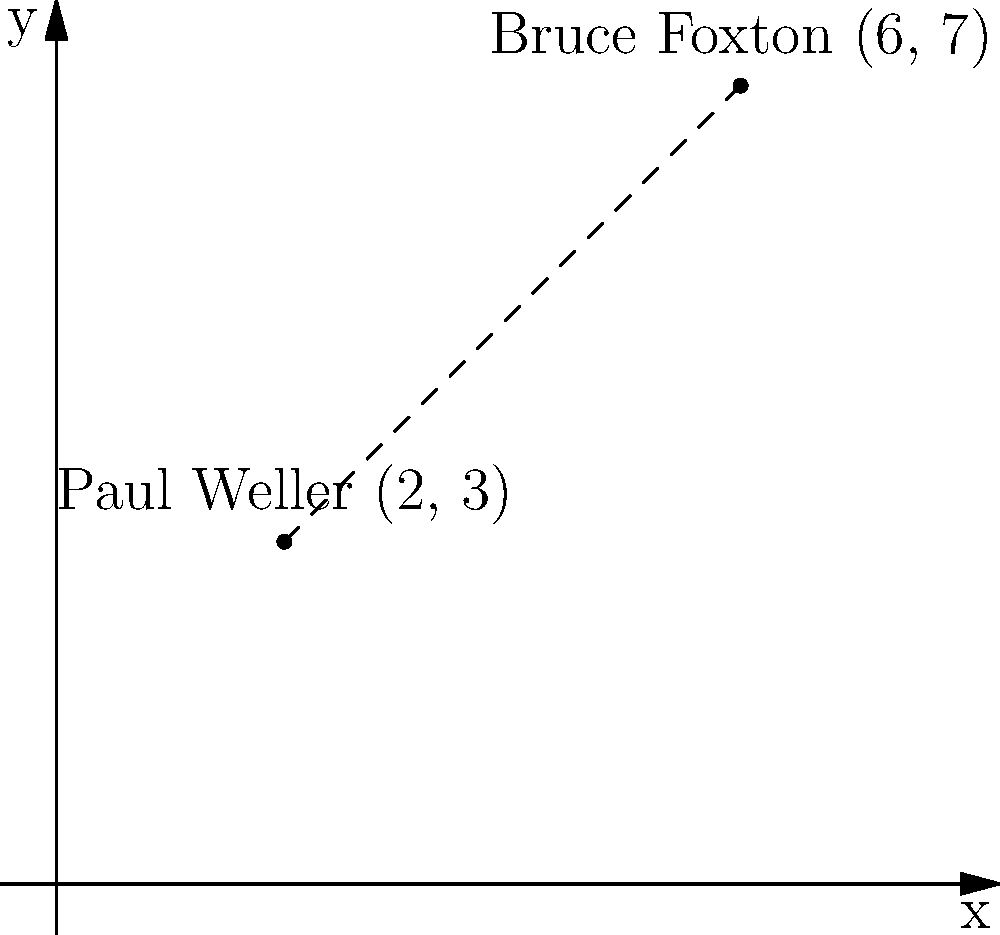During a performance of "Town Called Malice," Paul Weller and Bruce Foxton are positioned at different points on the stage. Paul is at coordinates (2, 3) and Bruce is at (6, 7). Calculate the distance between them using the distance formula. To solve this problem, we'll use the distance formula derived from the Pythagorean theorem:

$$ d = \sqrt{(x_2 - x_1)^2 + (y_2 - y_1)^2} $$

Where $(x_1, y_1)$ is Paul's position and $(x_2, y_2)$ is Bruce's position.

Step 1: Identify the coordinates
Paul Weller: $(x_1, y_1) = (2, 3)$
Bruce Foxton: $(x_2, y_2) = (6, 7)$

Step 2: Plug the values into the formula
$$ d = \sqrt{(6 - 2)^2 + (7 - 3)^2} $$

Step 3: Simplify the expressions inside the parentheses
$$ d = \sqrt{4^2 + 4^2} $$

Step 4: Calculate the squares
$$ d = \sqrt{16 + 16} $$

Step 5: Add the values under the square root
$$ d = \sqrt{32} $$

Step 6: Simplify the square root
$$ d = 4\sqrt{2} $$

Therefore, the distance between Paul Weller and Bruce Foxton on stage is $4\sqrt{2}$ units.
Answer: $4\sqrt{2}$ units 